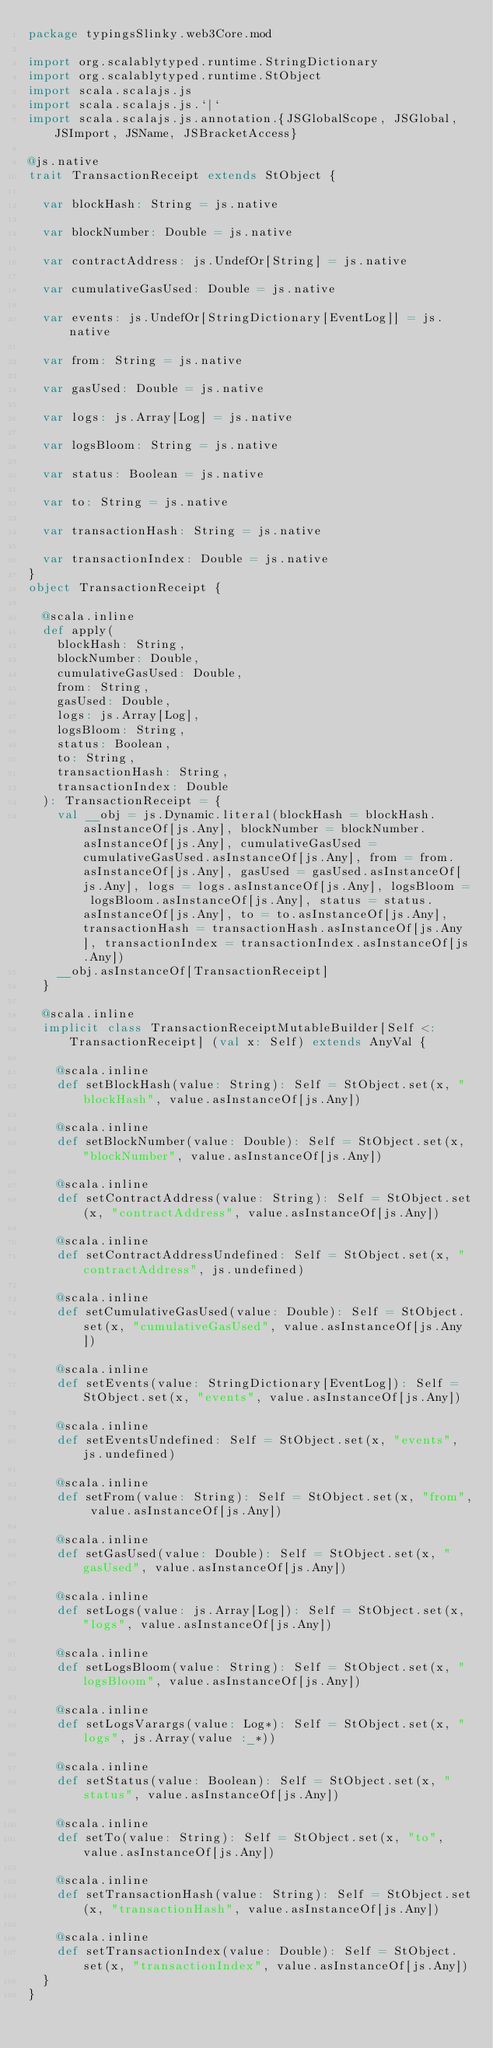Convert code to text. <code><loc_0><loc_0><loc_500><loc_500><_Scala_>package typingsSlinky.web3Core.mod

import org.scalablytyped.runtime.StringDictionary
import org.scalablytyped.runtime.StObject
import scala.scalajs.js
import scala.scalajs.js.`|`
import scala.scalajs.js.annotation.{JSGlobalScope, JSGlobal, JSImport, JSName, JSBracketAccess}

@js.native
trait TransactionReceipt extends StObject {
  
  var blockHash: String = js.native
  
  var blockNumber: Double = js.native
  
  var contractAddress: js.UndefOr[String] = js.native
  
  var cumulativeGasUsed: Double = js.native
  
  var events: js.UndefOr[StringDictionary[EventLog]] = js.native
  
  var from: String = js.native
  
  var gasUsed: Double = js.native
  
  var logs: js.Array[Log] = js.native
  
  var logsBloom: String = js.native
  
  var status: Boolean = js.native
  
  var to: String = js.native
  
  var transactionHash: String = js.native
  
  var transactionIndex: Double = js.native
}
object TransactionReceipt {
  
  @scala.inline
  def apply(
    blockHash: String,
    blockNumber: Double,
    cumulativeGasUsed: Double,
    from: String,
    gasUsed: Double,
    logs: js.Array[Log],
    logsBloom: String,
    status: Boolean,
    to: String,
    transactionHash: String,
    transactionIndex: Double
  ): TransactionReceipt = {
    val __obj = js.Dynamic.literal(blockHash = blockHash.asInstanceOf[js.Any], blockNumber = blockNumber.asInstanceOf[js.Any], cumulativeGasUsed = cumulativeGasUsed.asInstanceOf[js.Any], from = from.asInstanceOf[js.Any], gasUsed = gasUsed.asInstanceOf[js.Any], logs = logs.asInstanceOf[js.Any], logsBloom = logsBloom.asInstanceOf[js.Any], status = status.asInstanceOf[js.Any], to = to.asInstanceOf[js.Any], transactionHash = transactionHash.asInstanceOf[js.Any], transactionIndex = transactionIndex.asInstanceOf[js.Any])
    __obj.asInstanceOf[TransactionReceipt]
  }
  
  @scala.inline
  implicit class TransactionReceiptMutableBuilder[Self <: TransactionReceipt] (val x: Self) extends AnyVal {
    
    @scala.inline
    def setBlockHash(value: String): Self = StObject.set(x, "blockHash", value.asInstanceOf[js.Any])
    
    @scala.inline
    def setBlockNumber(value: Double): Self = StObject.set(x, "blockNumber", value.asInstanceOf[js.Any])
    
    @scala.inline
    def setContractAddress(value: String): Self = StObject.set(x, "contractAddress", value.asInstanceOf[js.Any])
    
    @scala.inline
    def setContractAddressUndefined: Self = StObject.set(x, "contractAddress", js.undefined)
    
    @scala.inline
    def setCumulativeGasUsed(value: Double): Self = StObject.set(x, "cumulativeGasUsed", value.asInstanceOf[js.Any])
    
    @scala.inline
    def setEvents(value: StringDictionary[EventLog]): Self = StObject.set(x, "events", value.asInstanceOf[js.Any])
    
    @scala.inline
    def setEventsUndefined: Self = StObject.set(x, "events", js.undefined)
    
    @scala.inline
    def setFrom(value: String): Self = StObject.set(x, "from", value.asInstanceOf[js.Any])
    
    @scala.inline
    def setGasUsed(value: Double): Self = StObject.set(x, "gasUsed", value.asInstanceOf[js.Any])
    
    @scala.inline
    def setLogs(value: js.Array[Log]): Self = StObject.set(x, "logs", value.asInstanceOf[js.Any])
    
    @scala.inline
    def setLogsBloom(value: String): Self = StObject.set(x, "logsBloom", value.asInstanceOf[js.Any])
    
    @scala.inline
    def setLogsVarargs(value: Log*): Self = StObject.set(x, "logs", js.Array(value :_*))
    
    @scala.inline
    def setStatus(value: Boolean): Self = StObject.set(x, "status", value.asInstanceOf[js.Any])
    
    @scala.inline
    def setTo(value: String): Self = StObject.set(x, "to", value.asInstanceOf[js.Any])
    
    @scala.inline
    def setTransactionHash(value: String): Self = StObject.set(x, "transactionHash", value.asInstanceOf[js.Any])
    
    @scala.inline
    def setTransactionIndex(value: Double): Self = StObject.set(x, "transactionIndex", value.asInstanceOf[js.Any])
  }
}
</code> 